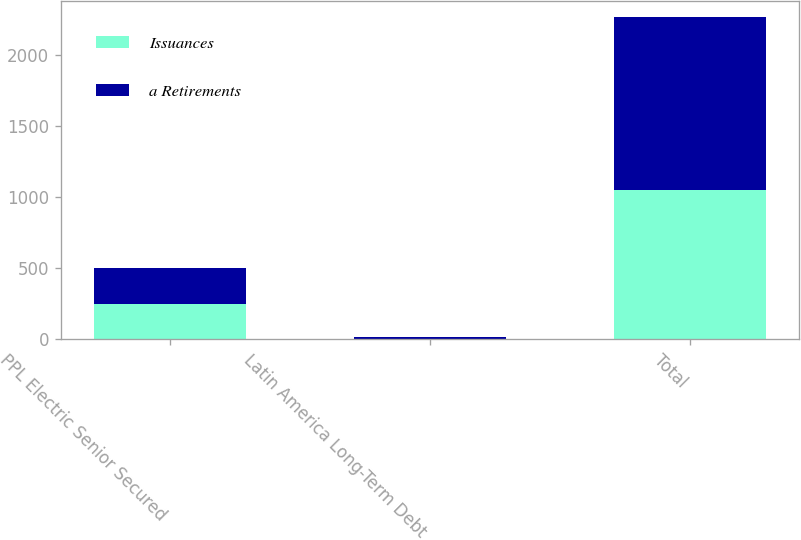Convert chart. <chart><loc_0><loc_0><loc_500><loc_500><stacked_bar_chart><ecel><fcel>PPL Electric Senior Secured<fcel>Latin America Long-Term Debt<fcel>Total<nl><fcel>Issuances<fcel>250<fcel>6<fcel>1047<nl><fcel>a Retirements<fcel>255<fcel>8<fcel>1217<nl></chart> 